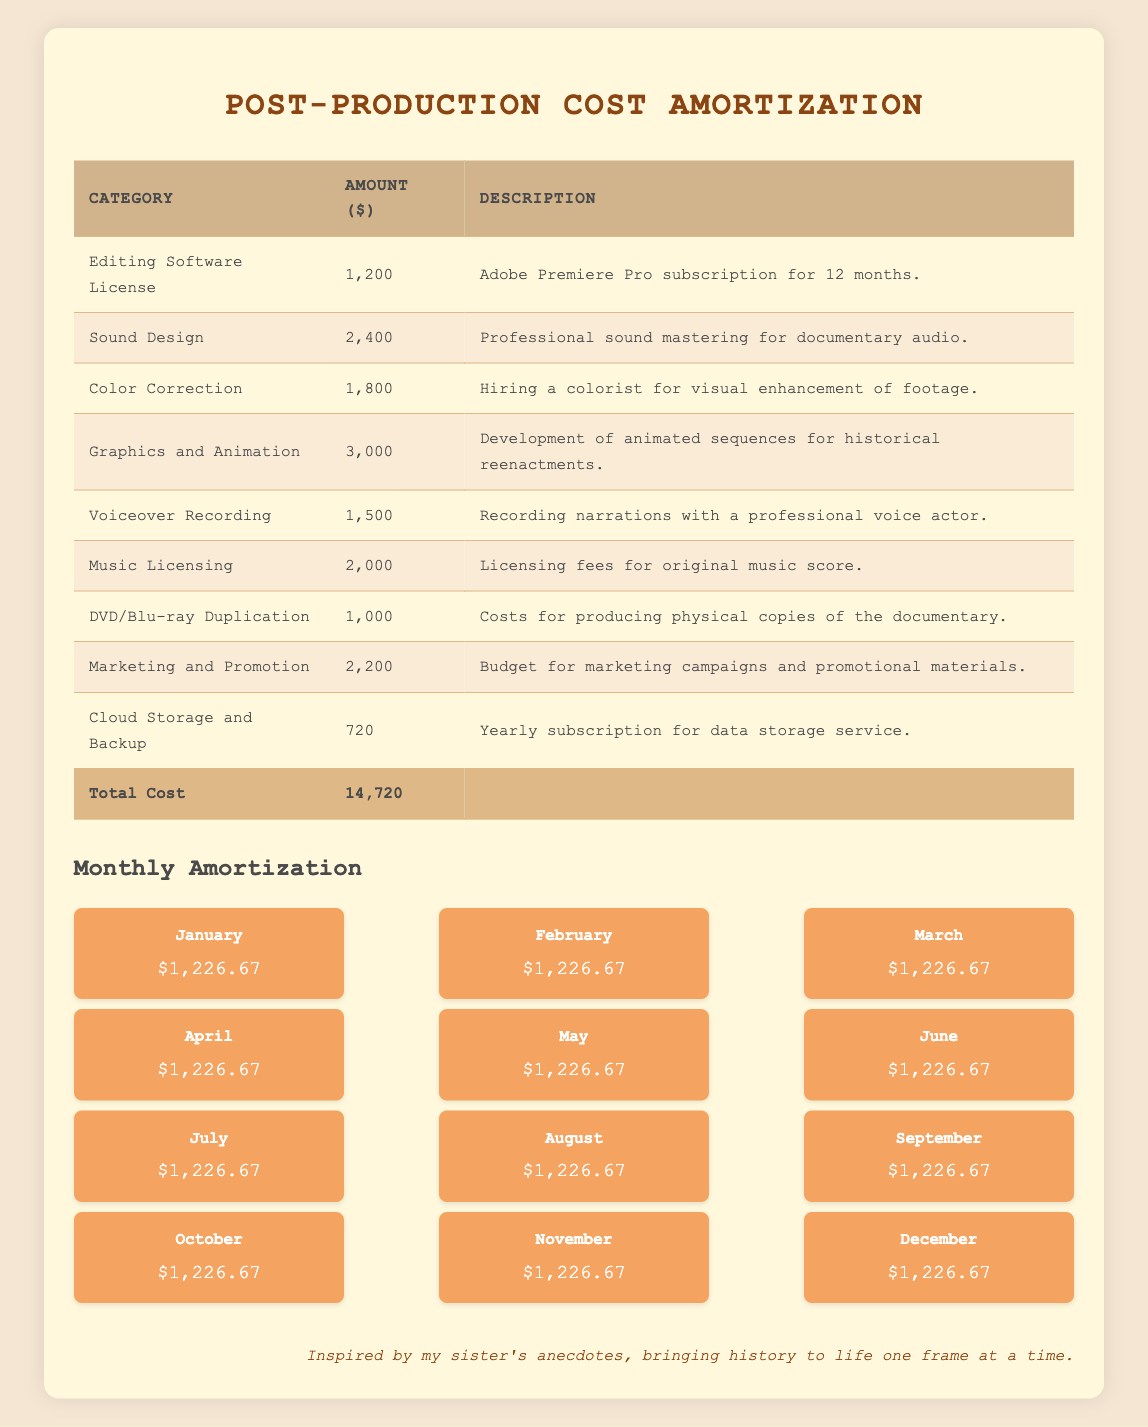What is the total cost of post-production? The total cost listed in the table under "Total Cost" is 14,720 dollars.
Answer: 14,720 How much is allocated for sound design? The amount allocated for sound design is listed as 2,400 dollars under that category in the table.
Answer: 2,400 Is the cost for DVD/Blu-ray duplication greater than the cost for cloud storage and backup? The cost for DVD/Blu-ray duplication is 1,000 dollars, while the cost for cloud storage and backup is 720 dollars. Since 1,000 is greater than 720, the answer is yes.
Answer: Yes What is the monthly amortization amount? The monthly amortization amount is provided as 1,226.67 dollars for each month from January to December in the amortization section of the table.
Answer: 1,226.67 What is the total amount for graphics and animation and voiceover recording combined? The amount for graphics and animation is 3,000 dollars, and the amount for voiceover recording is 1,500 dollars. Adding these two amounts together (3,000 + 1,500) gives 4,500 dollars.
Answer: 4,500 How many categories of costs are there in the post-production list? The post-production costs consist of 9 categories, each represented in its own row in the table.
Answer: 9 What is the average monthly amortization across the 12 months? The monthly amortization is consistent at 1,226.67 dollars for each of the 12 months. Therefore, the average monthly amortization is the same as the individual month amount, which is 1,226.67.
Answer: 1,226.67 Which category has the highest cost, and what is that cost? By reviewing the table, "Graphics and Animation" has the highest cost of 3,000 dollars.
Answer: 3,000 Is the total cost greater than the total of the monthly amortization for the year? The total over 12 months of amortization (1,226.67 * 12) equals 14,720. Since this equals the total cost, the statement is false; they are equal.
Answer: No 